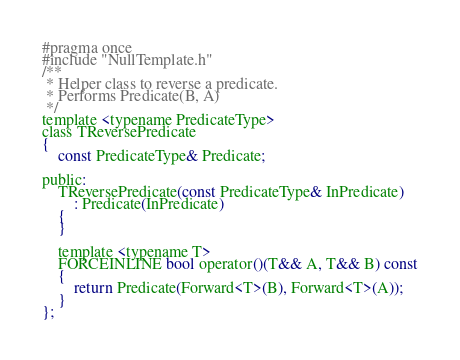Convert code to text. <code><loc_0><loc_0><loc_500><loc_500><_C_>#pragma once
#include "NullTemplate.h"
/**
 * Helper class to reverse a predicate.
 * Performs Predicate(B, A)
 */
template <typename PredicateType>
class TReversePredicate
{
	const PredicateType& Predicate;

public:
	TReversePredicate(const PredicateType& InPredicate)
		: Predicate(InPredicate)
	{
	}

	template <typename T>
	FORCEINLINE bool operator()(T&& A, T&& B) const
	{
		return Predicate(Forward<T>(B), Forward<T>(A));
	}
};

</code> 